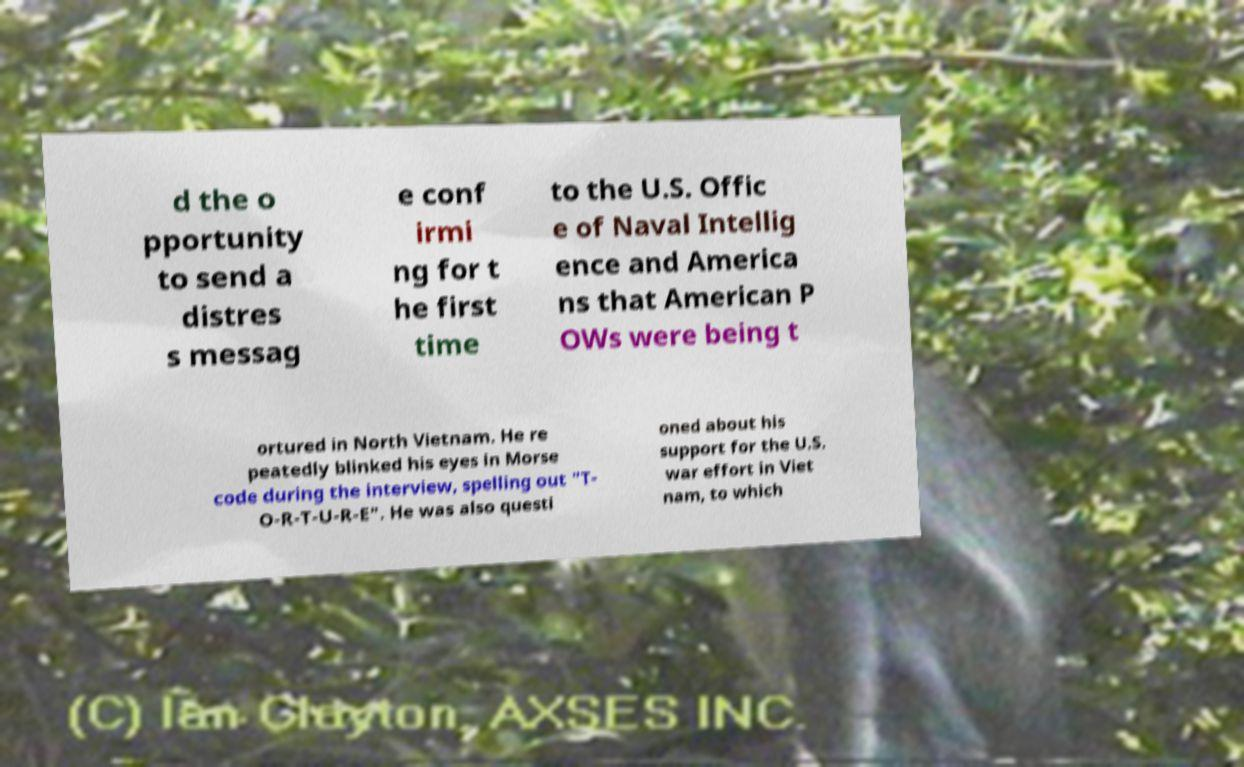What messages or text are displayed in this image? I need them in a readable, typed format. d the o pportunity to send a distres s messag e conf irmi ng for t he first time to the U.S. Offic e of Naval Intellig ence and America ns that American P OWs were being t ortured in North Vietnam. He re peatedly blinked his eyes in Morse code during the interview, spelling out "T- O-R-T-U-R-E". He was also questi oned about his support for the U.S. war effort in Viet nam, to which 